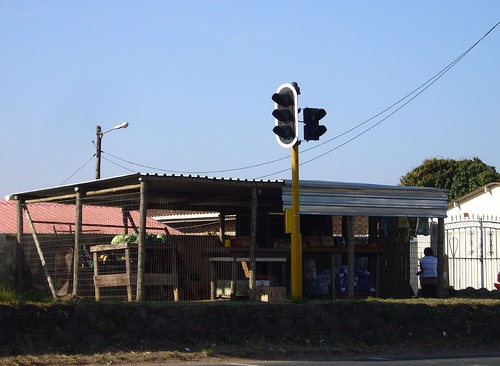Describe the objects in this image and their specific colors. I can see traffic light in lightblue, black, white, gray, and darkgray tones, traffic light in lightblue, black, navy, blue, and darkblue tones, and people in lightblue, black, navy, darkblue, and blue tones in this image. 